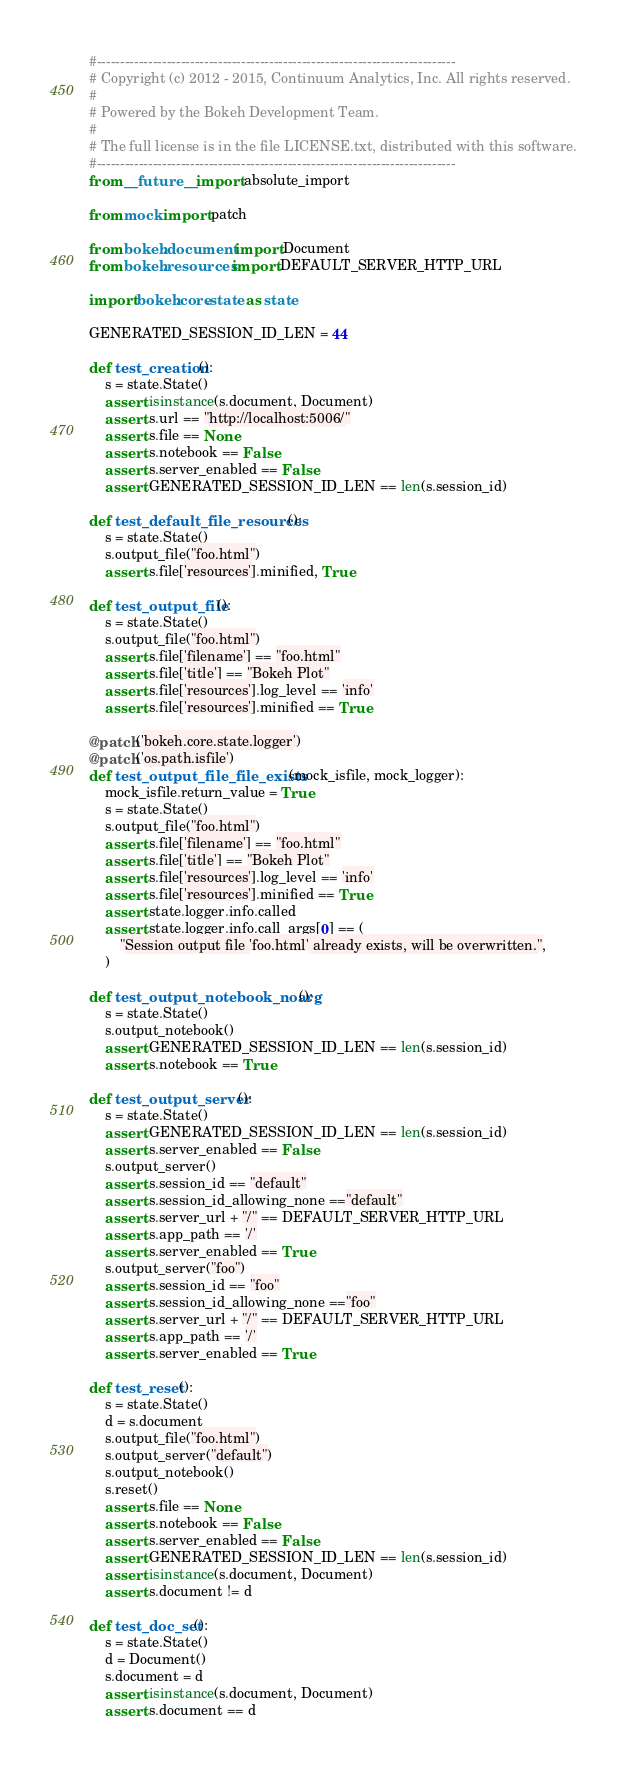<code> <loc_0><loc_0><loc_500><loc_500><_Python_>#-----------------------------------------------------------------------------
# Copyright (c) 2012 - 2015, Continuum Analytics, Inc. All rights reserved.
#
# Powered by the Bokeh Development Team.
#
# The full license is in the file LICENSE.txt, distributed with this software.
#-----------------------------------------------------------------------------
from __future__ import absolute_import

from mock import patch

from bokeh.document import Document
from bokeh.resources import DEFAULT_SERVER_HTTP_URL

import bokeh.core.state as state

GENERATED_SESSION_ID_LEN = 44

def test_creation():
    s = state.State()
    assert isinstance(s.document, Document)
    assert s.url == "http://localhost:5006/"
    assert s.file == None
    assert s.notebook == False
    assert s.server_enabled == False
    assert GENERATED_SESSION_ID_LEN == len(s.session_id)

def test_default_file_resources():
    s = state.State()
    s.output_file("foo.html")
    assert s.file['resources'].minified, True

def test_output_file():
    s = state.State()
    s.output_file("foo.html")
    assert s.file['filename'] == "foo.html"
    assert s.file['title'] == "Bokeh Plot"
    assert s.file['resources'].log_level == 'info'
    assert s.file['resources'].minified == True

@patch('bokeh.core.state.logger')
@patch('os.path.isfile')
def test_output_file_file_exists(mock_isfile, mock_logger):
    mock_isfile.return_value = True
    s = state.State()
    s.output_file("foo.html")
    assert s.file['filename'] == "foo.html"
    assert s.file['title'] == "Bokeh Plot"
    assert s.file['resources'].log_level == 'info'
    assert s.file['resources'].minified == True
    assert state.logger.info.called
    assert state.logger.info.call_args[0] == (
        "Session output file 'foo.html' already exists, will be overwritten.",
    )

def test_output_notebook_noarg():
    s = state.State()
    s.output_notebook()
    assert GENERATED_SESSION_ID_LEN == len(s.session_id)
    assert s.notebook == True

def test_output_server():
    s = state.State()
    assert GENERATED_SESSION_ID_LEN == len(s.session_id)
    assert s.server_enabled == False
    s.output_server()
    assert s.session_id == "default"
    assert s.session_id_allowing_none =="default"
    assert s.server_url + "/" == DEFAULT_SERVER_HTTP_URL
    assert s.app_path == '/'
    assert s.server_enabled == True
    s.output_server("foo")
    assert s.session_id == "foo"
    assert s.session_id_allowing_none =="foo"
    assert s.server_url + "/" == DEFAULT_SERVER_HTTP_URL
    assert s.app_path == '/'
    assert s.server_enabled == True

def test_reset():
    s = state.State()
    d = s.document
    s.output_file("foo.html")
    s.output_server("default")
    s.output_notebook()
    s.reset()
    assert s.file == None
    assert s.notebook == False
    assert s.server_enabled == False
    assert GENERATED_SESSION_ID_LEN == len(s.session_id)
    assert isinstance(s.document, Document)
    assert s.document != d

def test_doc_set():
    s = state.State()
    d = Document()
    s.document = d
    assert isinstance(s.document, Document)
    assert s.document == d
</code> 